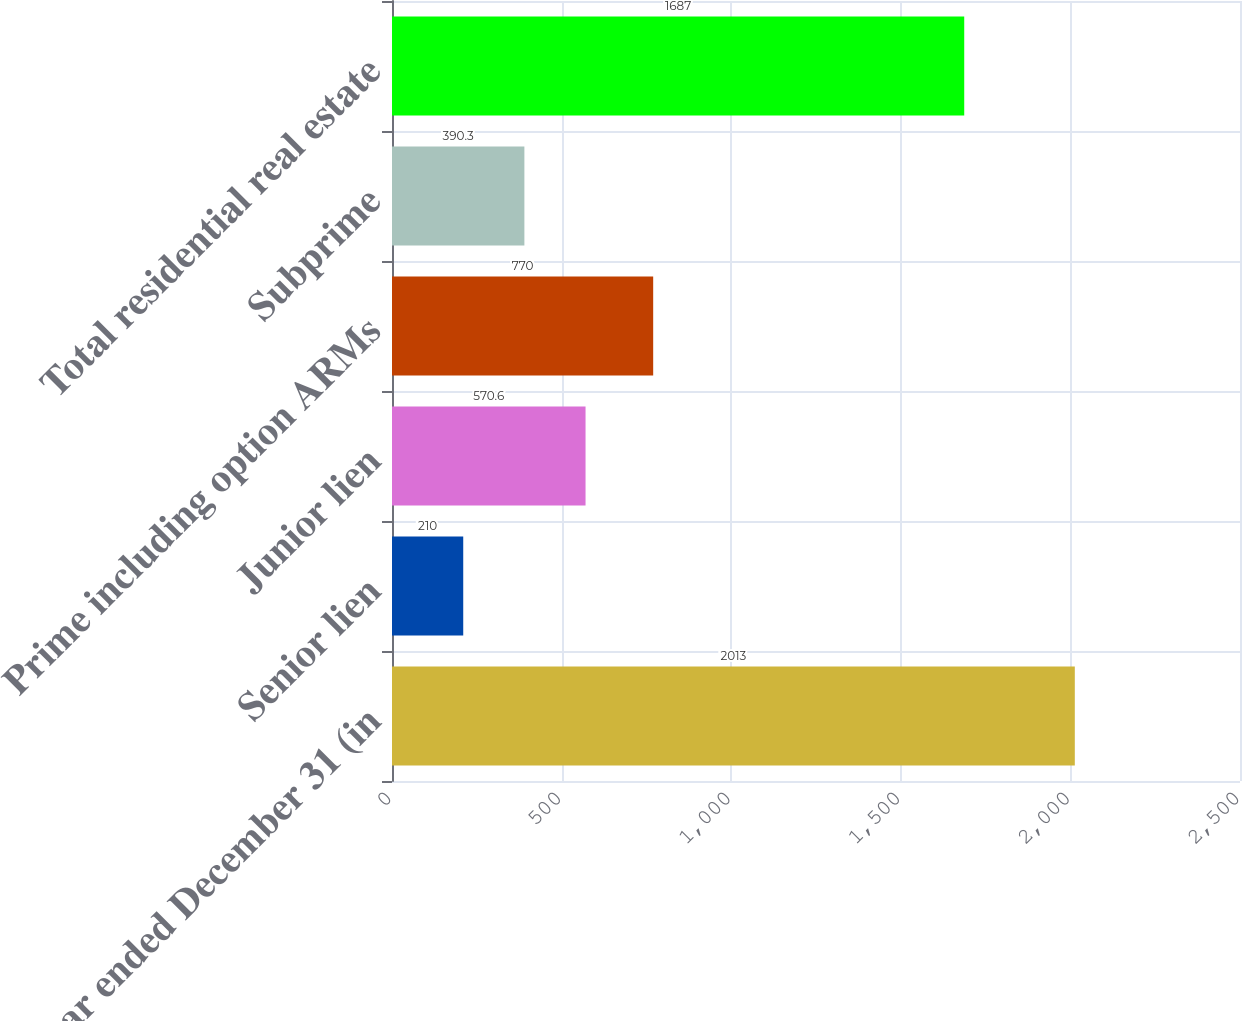Convert chart to OTSL. <chart><loc_0><loc_0><loc_500><loc_500><bar_chart><fcel>Year ended December 31 (in<fcel>Senior lien<fcel>Junior lien<fcel>Prime including option ARMs<fcel>Subprime<fcel>Total residential real estate<nl><fcel>2013<fcel>210<fcel>570.6<fcel>770<fcel>390.3<fcel>1687<nl></chart> 